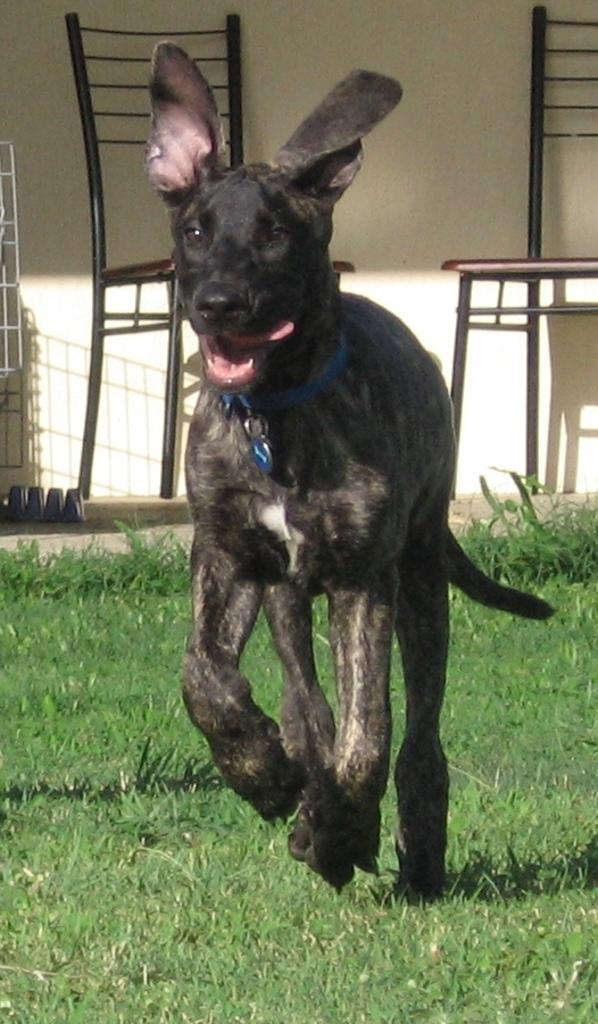What type of animal is in the image? There is a dog in the image. What is the dog doing in the image? The dog is running. What can be seen around the dog's neck? The dog has a blue belt around its neck. What is the color of the dog? The dog is black in color. What type of surface is the dog running on? There is grass on the ground in the image. What other objects are present in the image? There are chairs and a wall in the image. What type of pipe is the dog holding in its mouth in the image? There is no pipe present in the image; the dog is not holding anything in its mouth. 